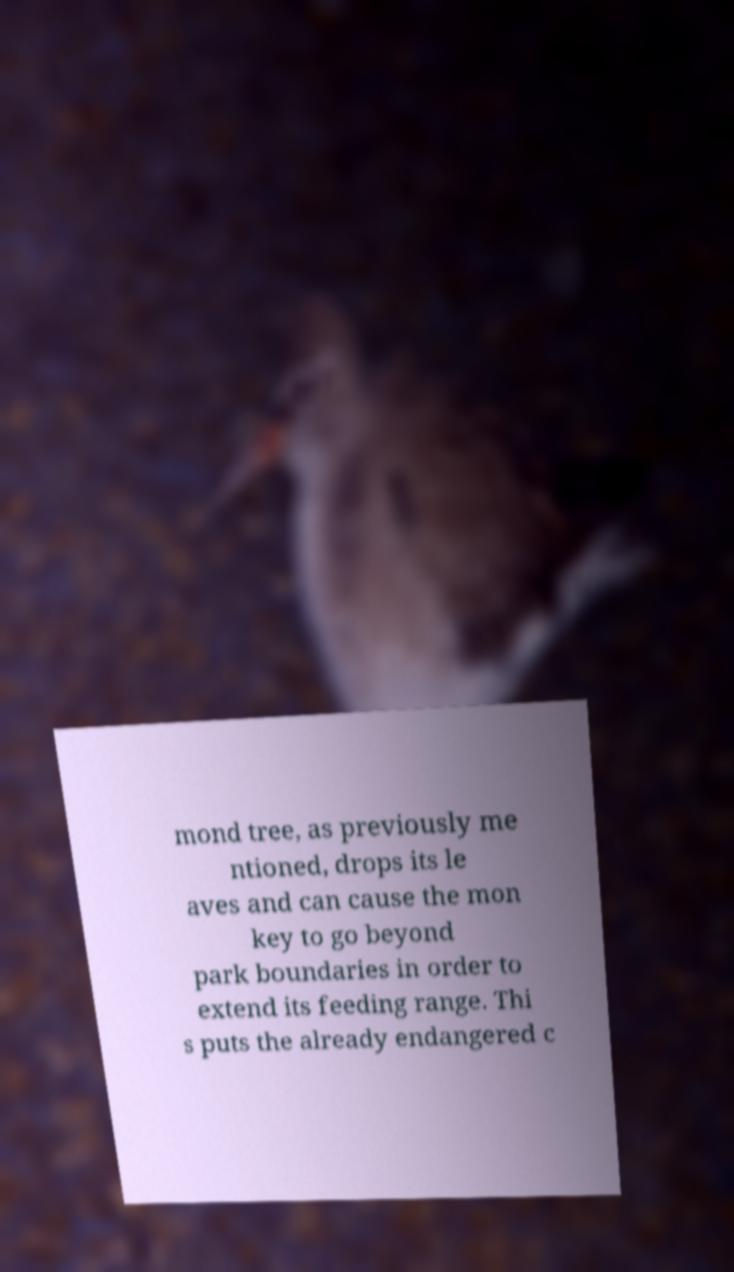Could you extract and type out the text from this image? mond tree, as previously me ntioned, drops its le aves and can cause the mon key to go beyond park boundaries in order to extend its feeding range. Thi s puts the already endangered c 